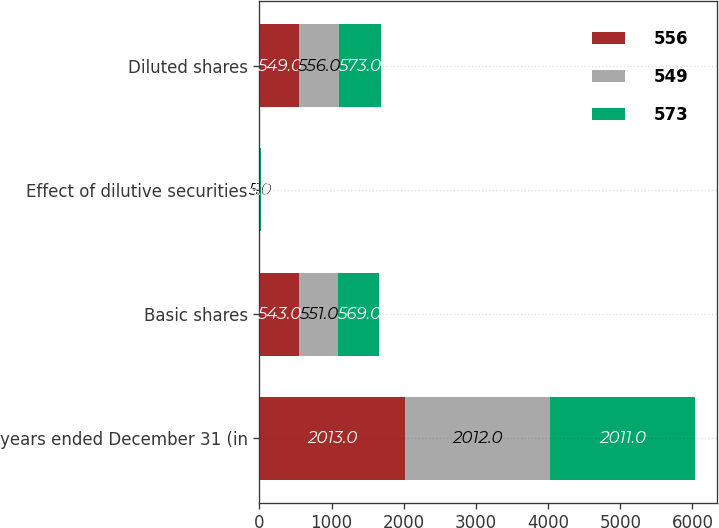Convert chart. <chart><loc_0><loc_0><loc_500><loc_500><stacked_bar_chart><ecel><fcel>years ended December 31 (in<fcel>Basic shares<fcel>Effect of dilutive securities<fcel>Diluted shares<nl><fcel>556<fcel>2013<fcel>543<fcel>6<fcel>549<nl><fcel>549<fcel>2012<fcel>551<fcel>5<fcel>556<nl><fcel>573<fcel>2011<fcel>569<fcel>4<fcel>573<nl></chart> 